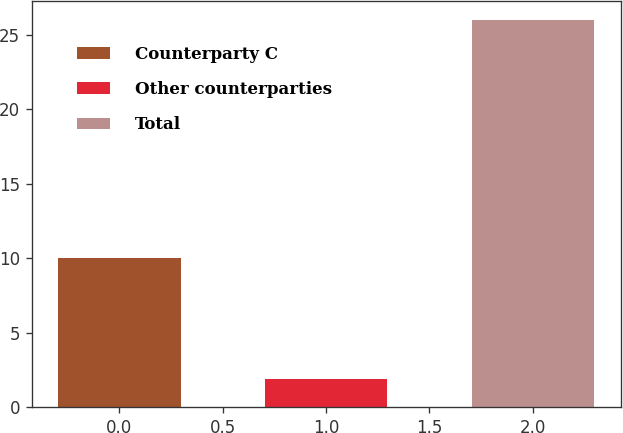Convert chart. <chart><loc_0><loc_0><loc_500><loc_500><bar_chart><fcel>Counterparty C<fcel>Other counterparties<fcel>Total<nl><fcel>10<fcel>1.9<fcel>26<nl></chart> 